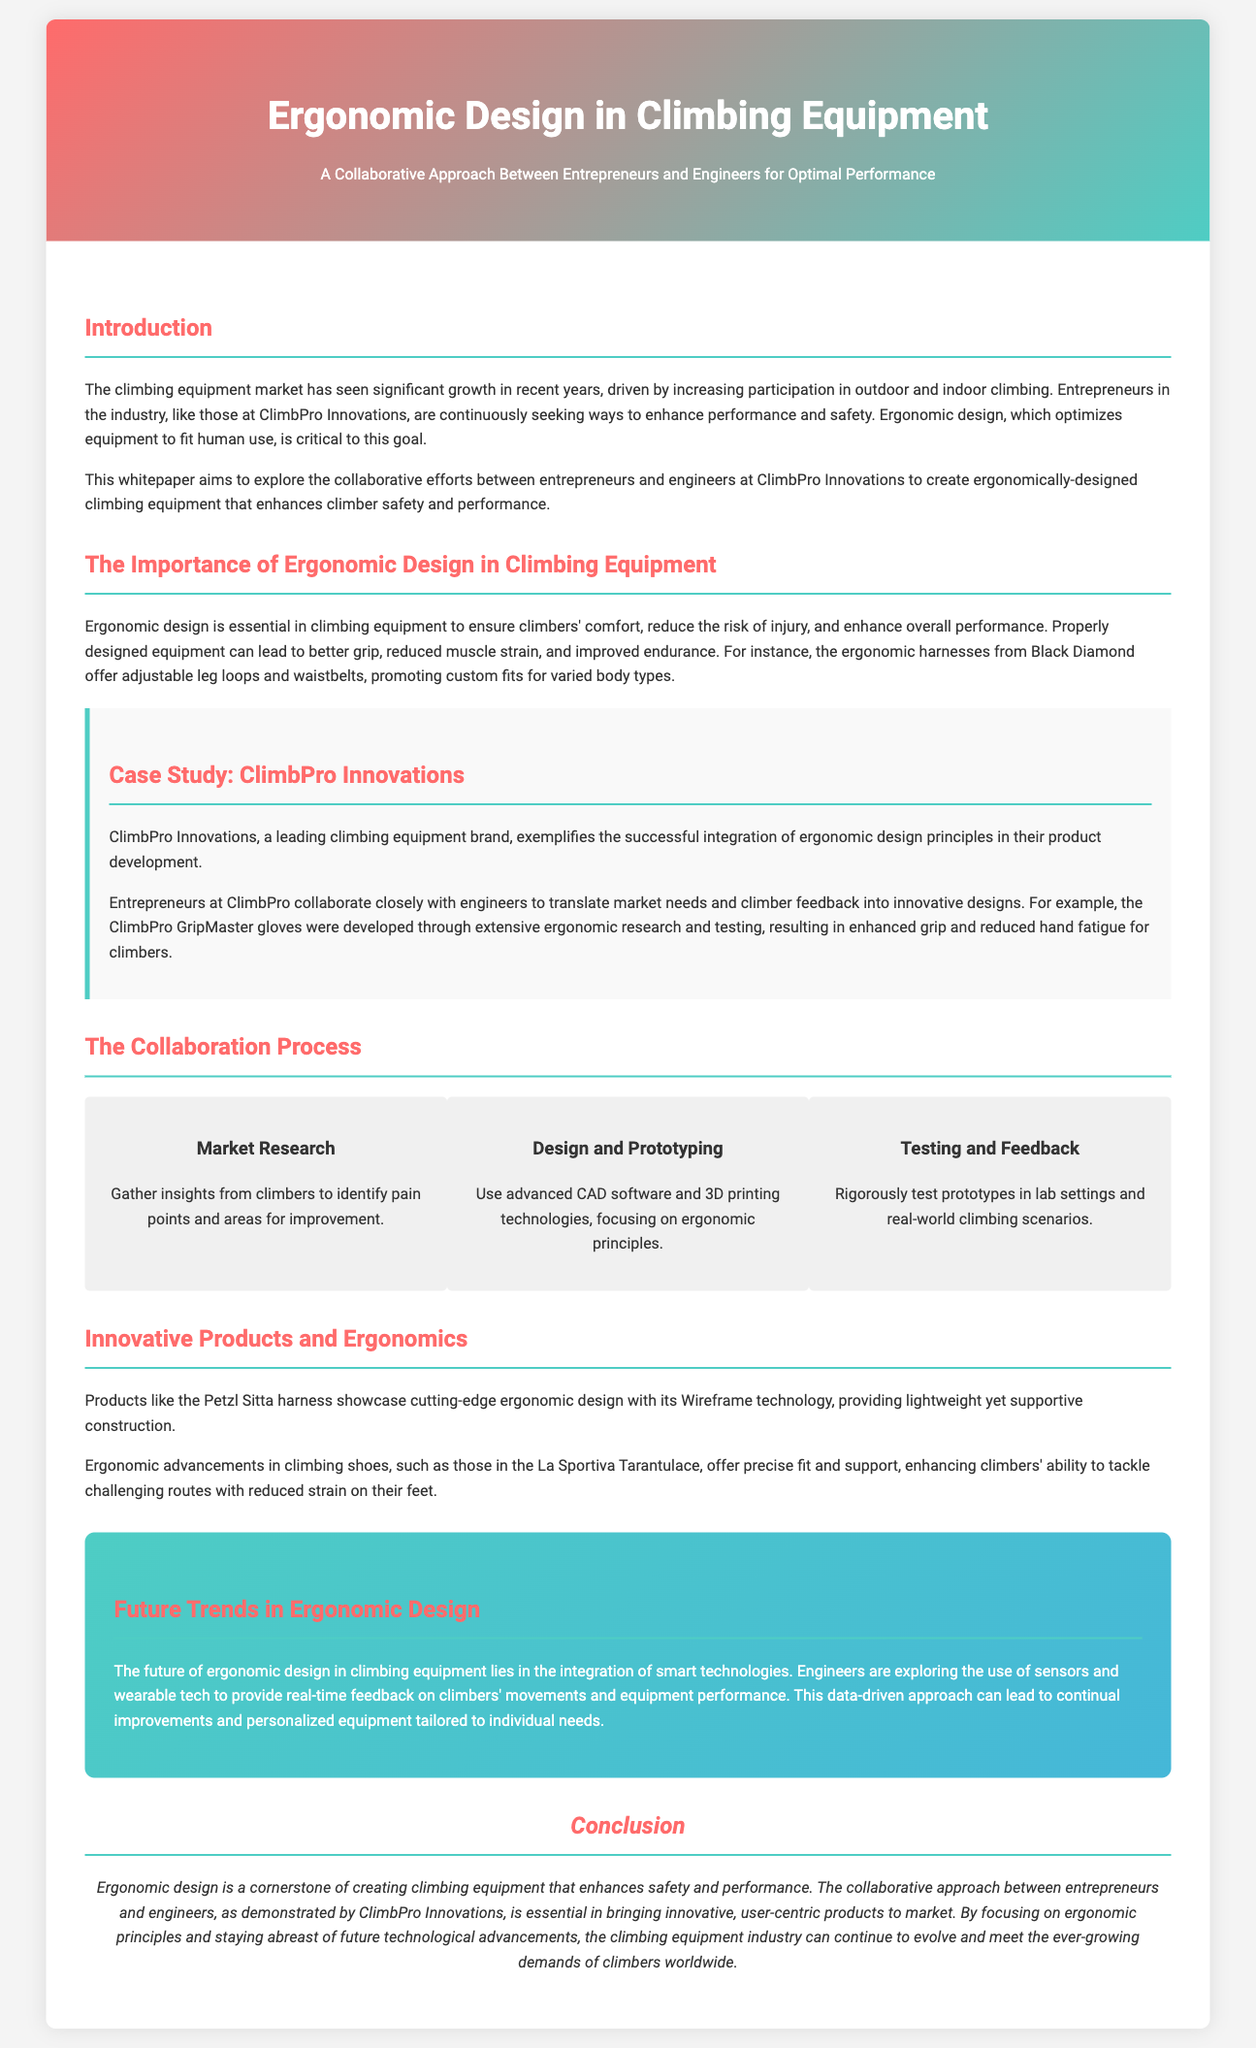what is the name of the climbing equipment brand highlighted in the document? The document discusses ClimbPro Innovations as a leading climbing equipment brand.
Answer: ClimbPro Innovations what is the main benefit of ergonomic design in climbing equipment? Ergonomic design is meant to improve climber comfort and reduce the risk of injury.
Answer: Comfort how does ClimbPro Innovations gather insights for their product development? They gather insights through market research to identify pain points and improvement areas.
Answer: Market research what technology is mentioned as showcasing cutting-edge ergonomic design in climbing harnesses? The document mentions Wireframe technology in the Petzl Sitta harness.
Answer: Wireframe technology what is one of the future trends in ergonomic design noted in the document? The future trend involves the integration of smart technologies in climbing equipment.
Answer: Smart technologies how do entrepreneurs and engineers work together in product development, according to the whitepaper? Entrepreneurs and engineers collaborate to translate market needs and climber feedback into designs.
Answer: Collaborate what is the title of the whitepaper? The title provides a clear indication of the focus on ergonomic design and collaboration.
Answer: Ergonomic Design in Climbing Equipment what product was developed as a result of ClimbPro Innovations' ergonomic research? The ClimbPro GripMaster gloves are a product of their ergonomic research.
Answer: ClimbPro GripMaster gloves 